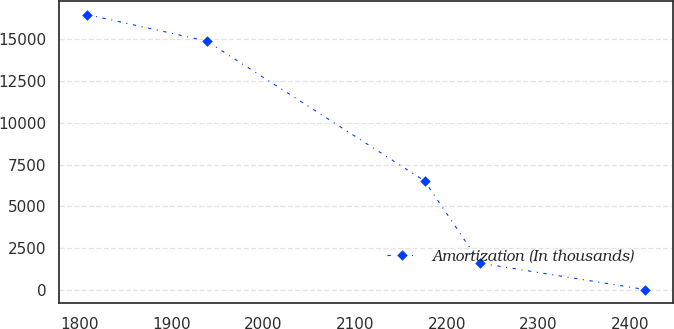<chart> <loc_0><loc_0><loc_500><loc_500><line_chart><ecel><fcel>Amortization (In thousands)<nl><fcel>1807.99<fcel>16468.5<nl><fcel>1938.15<fcel>14890.9<nl><fcel>2175.71<fcel>6527.9<nl><fcel>2236.57<fcel>1600.62<nl><fcel>2416.64<fcel>23.08<nl></chart> 